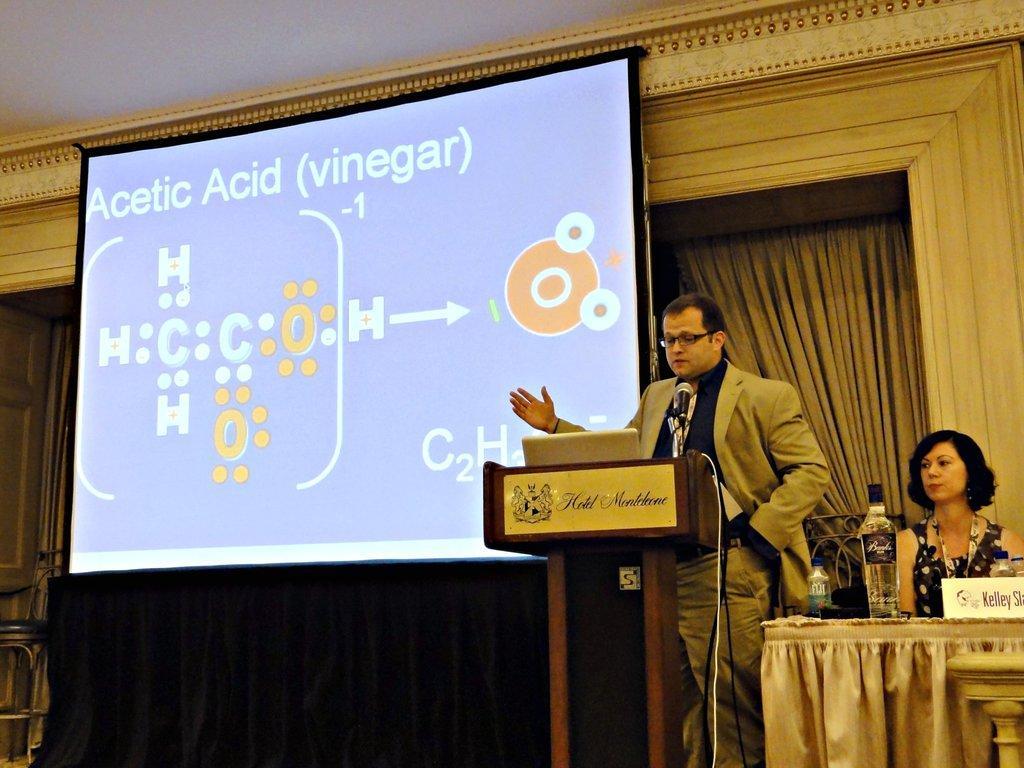How would you summarize this image in a sentence or two? As we can see in the image there is a screen, curtain, two people over here and there is a table. On table there is a poster and bottles. 